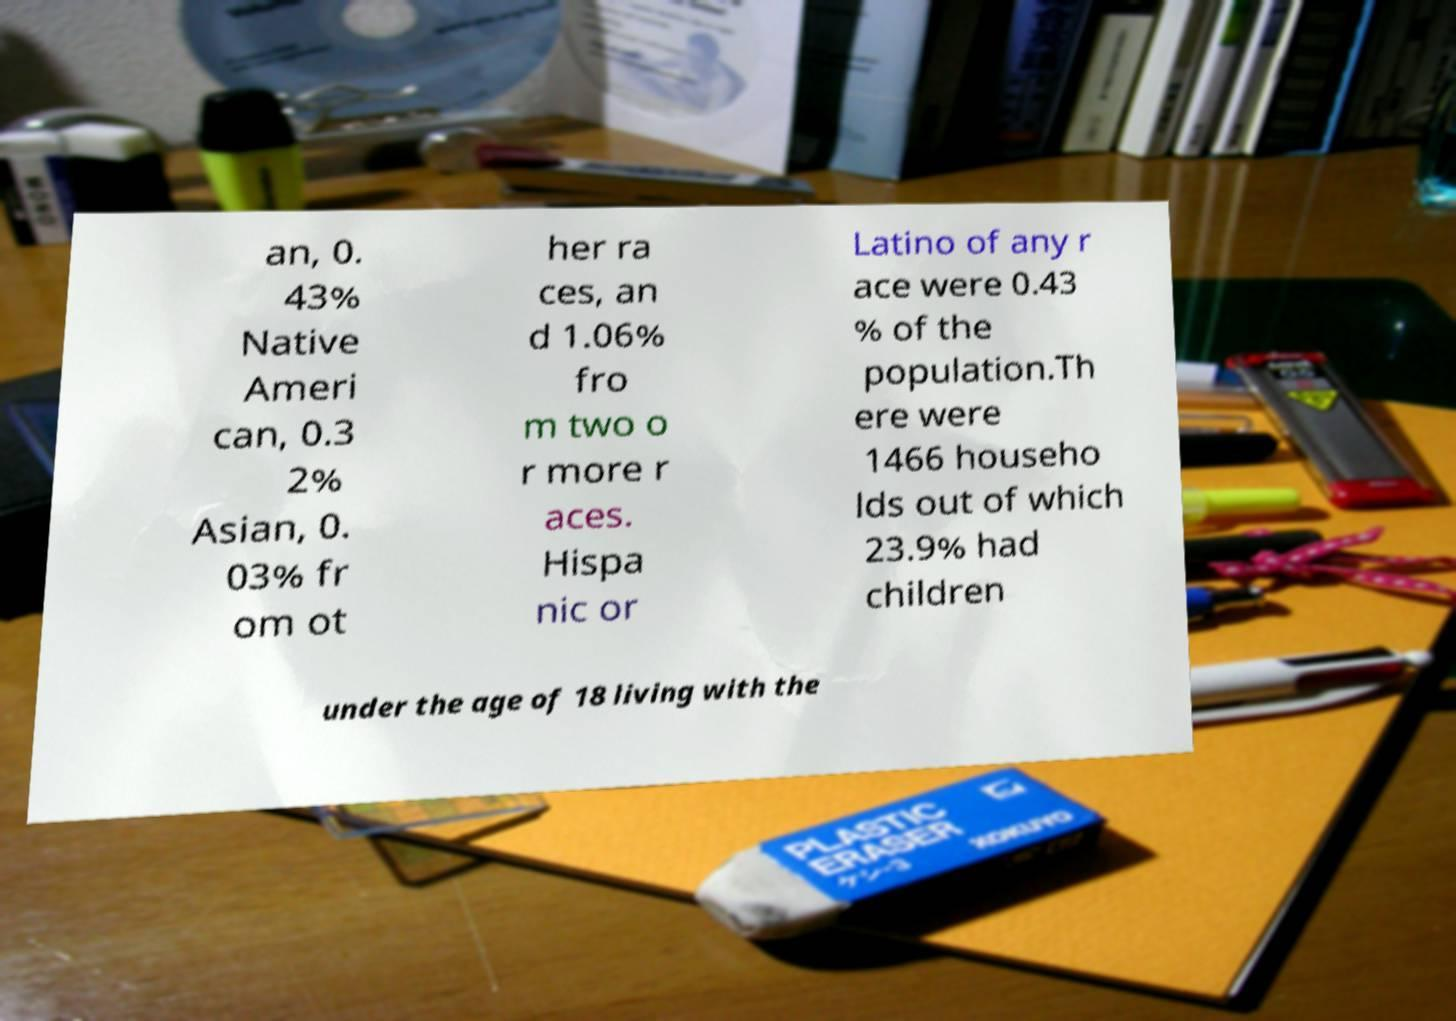Can you read and provide the text displayed in the image?This photo seems to have some interesting text. Can you extract and type it out for me? an, 0. 43% Native Ameri can, 0.3 2% Asian, 0. 03% fr om ot her ra ces, an d 1.06% fro m two o r more r aces. Hispa nic or Latino of any r ace were 0.43 % of the population.Th ere were 1466 househo lds out of which 23.9% had children under the age of 18 living with the 